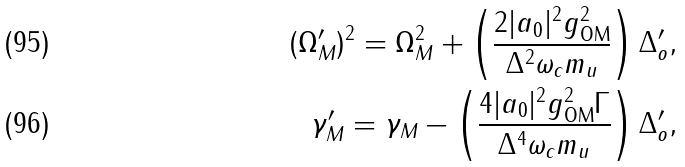<formula> <loc_0><loc_0><loc_500><loc_500>( \Omega _ { M } ^ { \prime } ) ^ { 2 } = \Omega _ { M } ^ { 2 } + \left ( \frac { 2 | a _ { 0 } | ^ { 2 } g _ { \text {OM} } ^ { 2 } } { \Delta ^ { 2 } \omega _ { c } m _ { u } } \right ) \Delta _ { o } ^ { \prime } , \\ \gamma _ { M } ^ { \prime } = \gamma _ { M } - \left ( \frac { 4 | a _ { 0 } | ^ { 2 } g _ { \text {OM} } ^ { 2 } \Gamma } { \Delta ^ { 4 } \omega _ { c } m _ { u } } \right ) \Delta _ { o } ^ { \prime } ,</formula> 